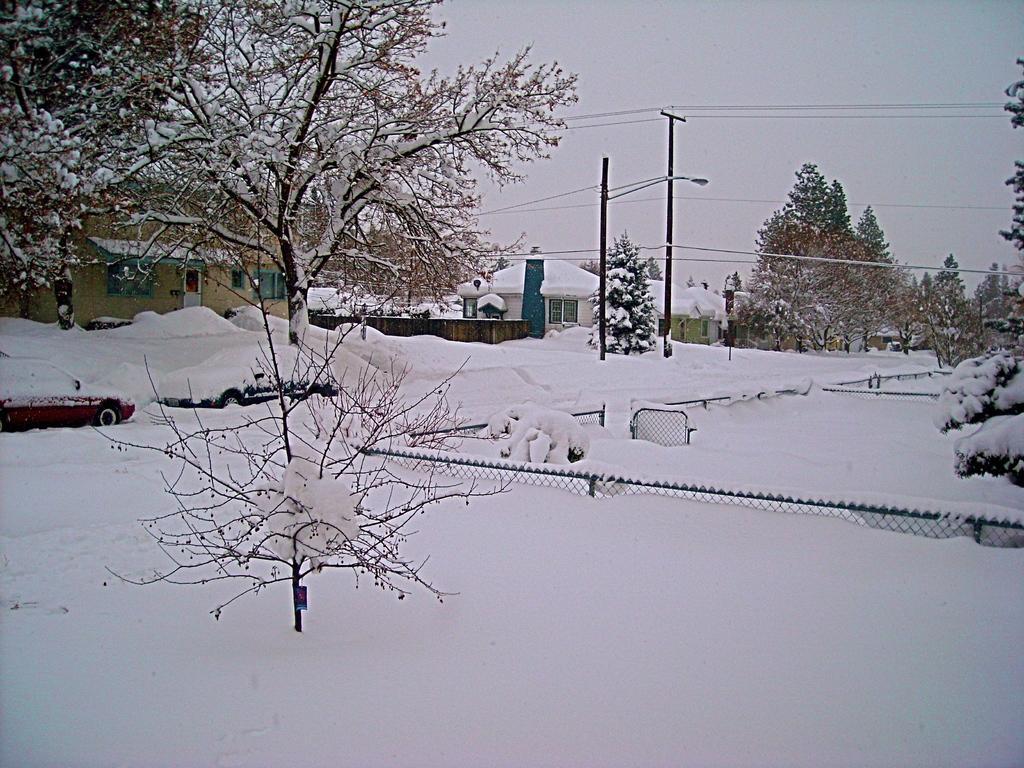In one or two sentences, can you explain what this image depicts? In this picture I can see some houses, trees, vehicles on the road are fully covered with snow. 